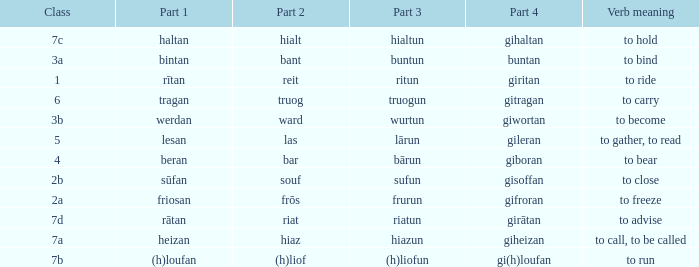What class in the word with part 4 "giheizan"? 7a. 